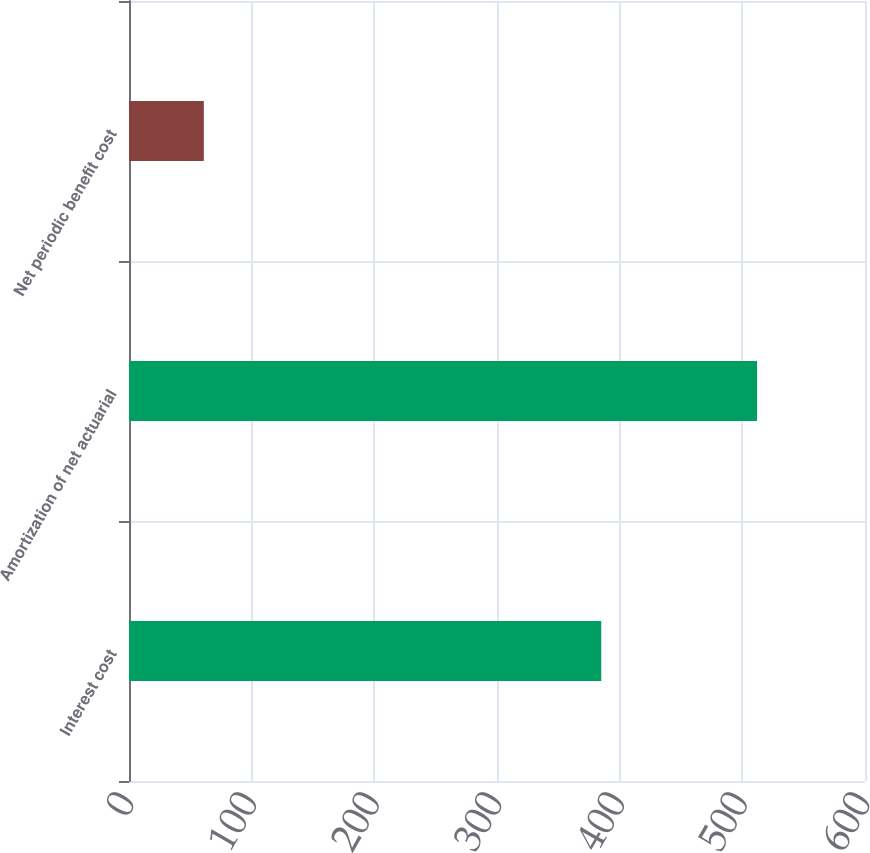Convert chart. <chart><loc_0><loc_0><loc_500><loc_500><bar_chart><fcel>Interest cost<fcel>Amortization of net actuarial<fcel>Net periodic benefit cost<nl><fcel>385<fcel>512<fcel>61<nl></chart> 